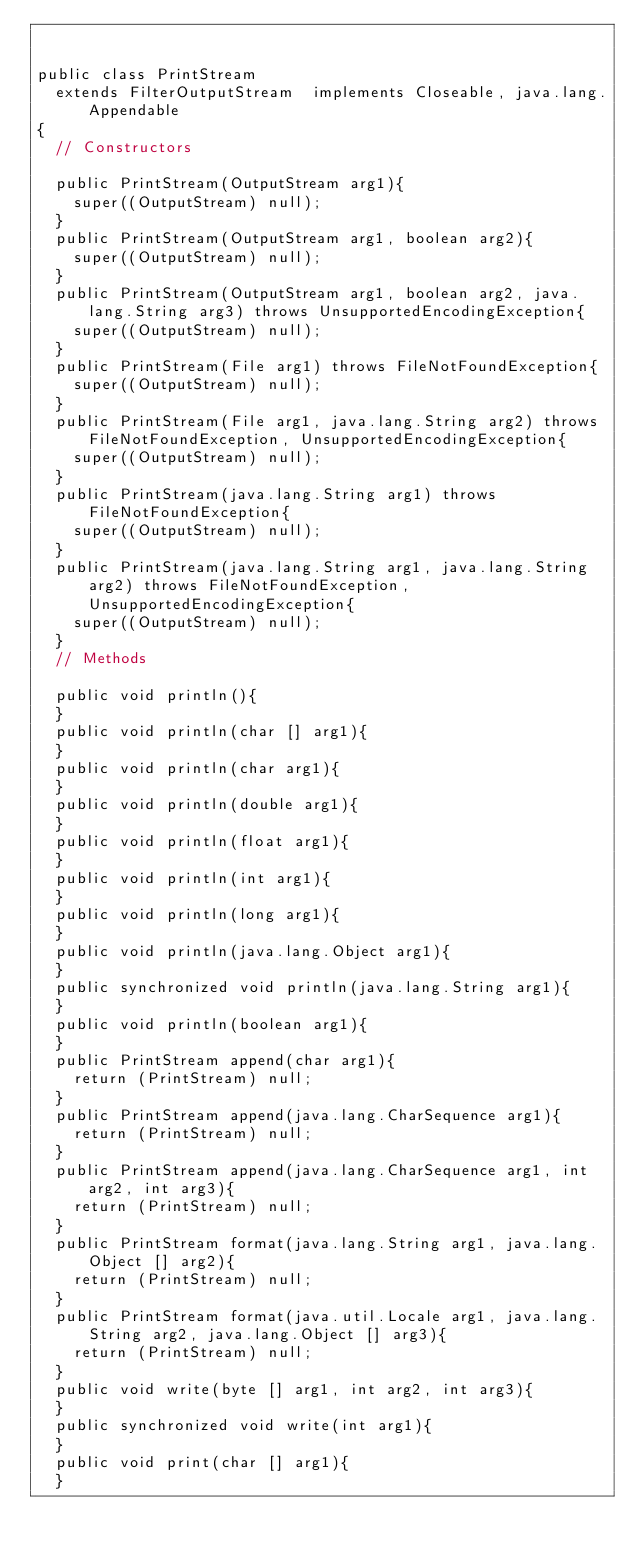Convert code to text. <code><loc_0><loc_0><loc_500><loc_500><_Java_>

public class PrintStream
  extends FilterOutputStream  implements Closeable, java.lang.Appendable
{
  // Constructors

  public PrintStream(OutputStream arg1){
    super((OutputStream) null);
  }
  public PrintStream(OutputStream arg1, boolean arg2){
    super((OutputStream) null);
  }
  public PrintStream(OutputStream arg1, boolean arg2, java.lang.String arg3) throws UnsupportedEncodingException{
    super((OutputStream) null);
  }
  public PrintStream(File arg1) throws FileNotFoundException{
    super((OutputStream) null);
  }
  public PrintStream(File arg1, java.lang.String arg2) throws FileNotFoundException, UnsupportedEncodingException{
    super((OutputStream) null);
  }
  public PrintStream(java.lang.String arg1) throws FileNotFoundException{
    super((OutputStream) null);
  }
  public PrintStream(java.lang.String arg1, java.lang.String arg2) throws FileNotFoundException, UnsupportedEncodingException{
    super((OutputStream) null);
  }
  // Methods

  public void println(){
  }
  public void println(char [] arg1){
  }
  public void println(char arg1){
  }
  public void println(double arg1){
  }
  public void println(float arg1){
  }
  public void println(int arg1){
  }
  public void println(long arg1){
  }
  public void println(java.lang.Object arg1){
  }
  public synchronized void println(java.lang.String arg1){
  }
  public void println(boolean arg1){
  }
  public PrintStream append(char arg1){
    return (PrintStream) null;
  }
  public PrintStream append(java.lang.CharSequence arg1){
    return (PrintStream) null;
  }
  public PrintStream append(java.lang.CharSequence arg1, int arg2, int arg3){
    return (PrintStream) null;
  }
  public PrintStream format(java.lang.String arg1, java.lang.Object [] arg2){
    return (PrintStream) null;
  }
  public PrintStream format(java.util.Locale arg1, java.lang.String arg2, java.lang.Object [] arg3){
    return (PrintStream) null;
  }
  public void write(byte [] arg1, int arg2, int arg3){
  }
  public synchronized void write(int arg1){
  }
  public void print(char [] arg1){
  }</code> 